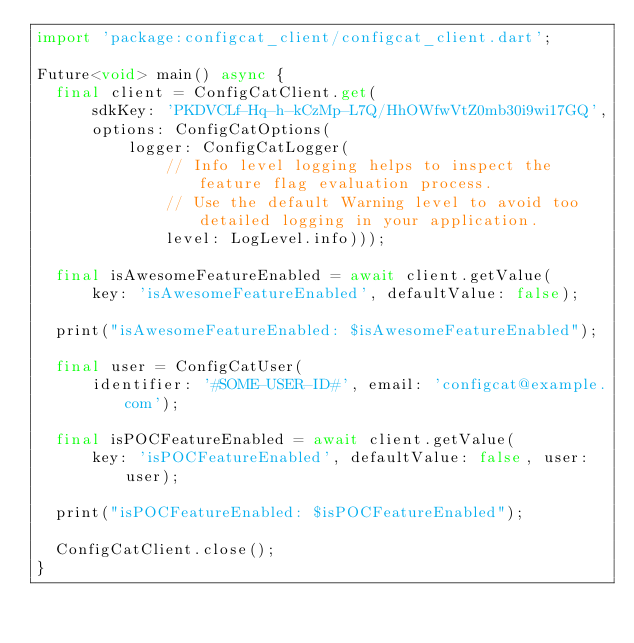<code> <loc_0><loc_0><loc_500><loc_500><_Dart_>import 'package:configcat_client/configcat_client.dart';

Future<void> main() async {
  final client = ConfigCatClient.get(
      sdkKey: 'PKDVCLf-Hq-h-kCzMp-L7Q/HhOWfwVtZ0mb30i9wi17GQ',
      options: ConfigCatOptions(
          logger: ConfigCatLogger(
              // Info level logging helps to inspect the feature flag evaluation process.
              // Use the default Warning level to avoid too detailed logging in your application.
              level: LogLevel.info)));

  final isAwesomeFeatureEnabled = await client.getValue(
      key: 'isAwesomeFeatureEnabled', defaultValue: false);

  print("isAwesomeFeatureEnabled: $isAwesomeFeatureEnabled");

  final user = ConfigCatUser(
      identifier: '#SOME-USER-ID#', email: 'configcat@example.com');

  final isPOCFeatureEnabled = await client.getValue(
      key: 'isPOCFeatureEnabled', defaultValue: false, user: user);

  print("isPOCFeatureEnabled: $isPOCFeatureEnabled");

  ConfigCatClient.close();
}
</code> 